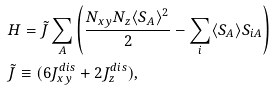<formula> <loc_0><loc_0><loc_500><loc_500>& H = \tilde { J } \sum _ { A } \left ( \frac { N _ { x y } N _ { z } \langle S _ { A } \rangle ^ { 2 } } { 2 } - \sum _ { i } \langle S _ { A } \rangle S _ { i A } \right ) \\ & \tilde { J } \equiv ( 6 J _ { x y } ^ { d i s } + 2 J _ { z } ^ { d i s } ) , \\</formula> 